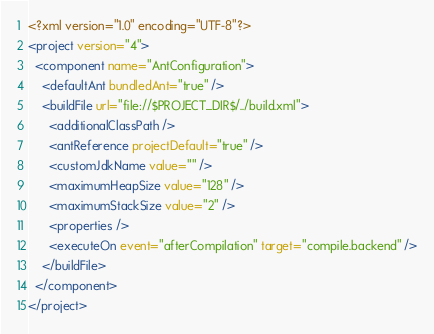Convert code to text. <code><loc_0><loc_0><loc_500><loc_500><_XML_><?xml version="1.0" encoding="UTF-8"?>
<project version="4">
  <component name="AntConfiguration">
    <defaultAnt bundledAnt="true" />
    <buildFile url="file://$PROJECT_DIR$/../build.xml">
      <additionalClassPath />
      <antReference projectDefault="true" />
      <customJdkName value="" />
      <maximumHeapSize value="128" />
      <maximumStackSize value="2" />
      <properties />
      <executeOn event="afterCompilation" target="compile.backend" />
    </buildFile>
  </component>
</project>

</code> 